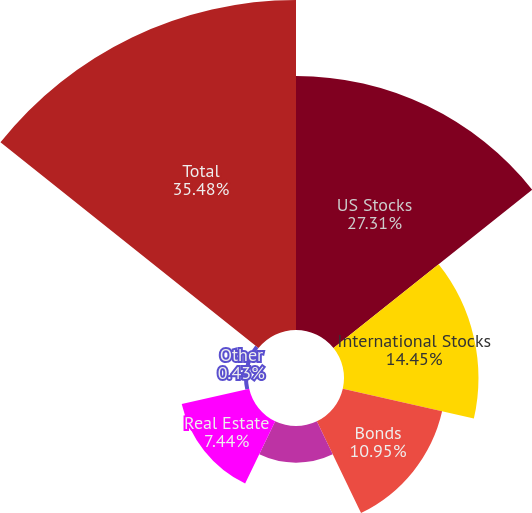Convert chart to OTSL. <chart><loc_0><loc_0><loc_500><loc_500><pie_chart><fcel>US Stocks<fcel>International Stocks<fcel>Bonds<fcel>Short-term Investments<fcel>Real Estate<fcel>Other<fcel>Total<nl><fcel>27.31%<fcel>14.45%<fcel>10.95%<fcel>3.94%<fcel>7.44%<fcel>0.43%<fcel>35.47%<nl></chart> 